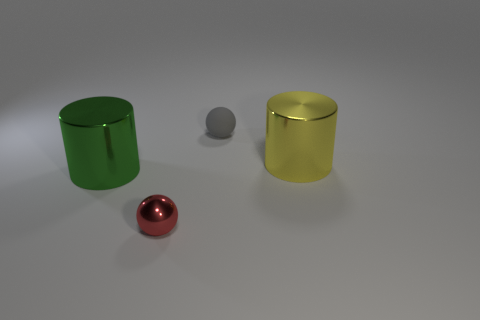Add 1 small gray metallic things. How many objects exist? 5 Subtract all blue cylinders. How many red balls are left? 1 Subtract all red metal spheres. Subtract all big yellow cylinders. How many objects are left? 2 Add 3 small red metallic balls. How many small red metallic balls are left? 4 Add 2 large yellow things. How many large yellow things exist? 3 Subtract all yellow cylinders. How many cylinders are left? 1 Subtract 0 blue cubes. How many objects are left? 4 Subtract 1 balls. How many balls are left? 1 Subtract all red balls. Subtract all green cylinders. How many balls are left? 1 